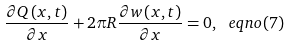Convert formula to latex. <formula><loc_0><loc_0><loc_500><loc_500>\frac { \partial Q \left ( x , t \right ) } { \partial x } + 2 \pi R \frac { \partial w \left ( x , t \right ) } { \partial x } = 0 , \ e q n o ( 7 )</formula> 